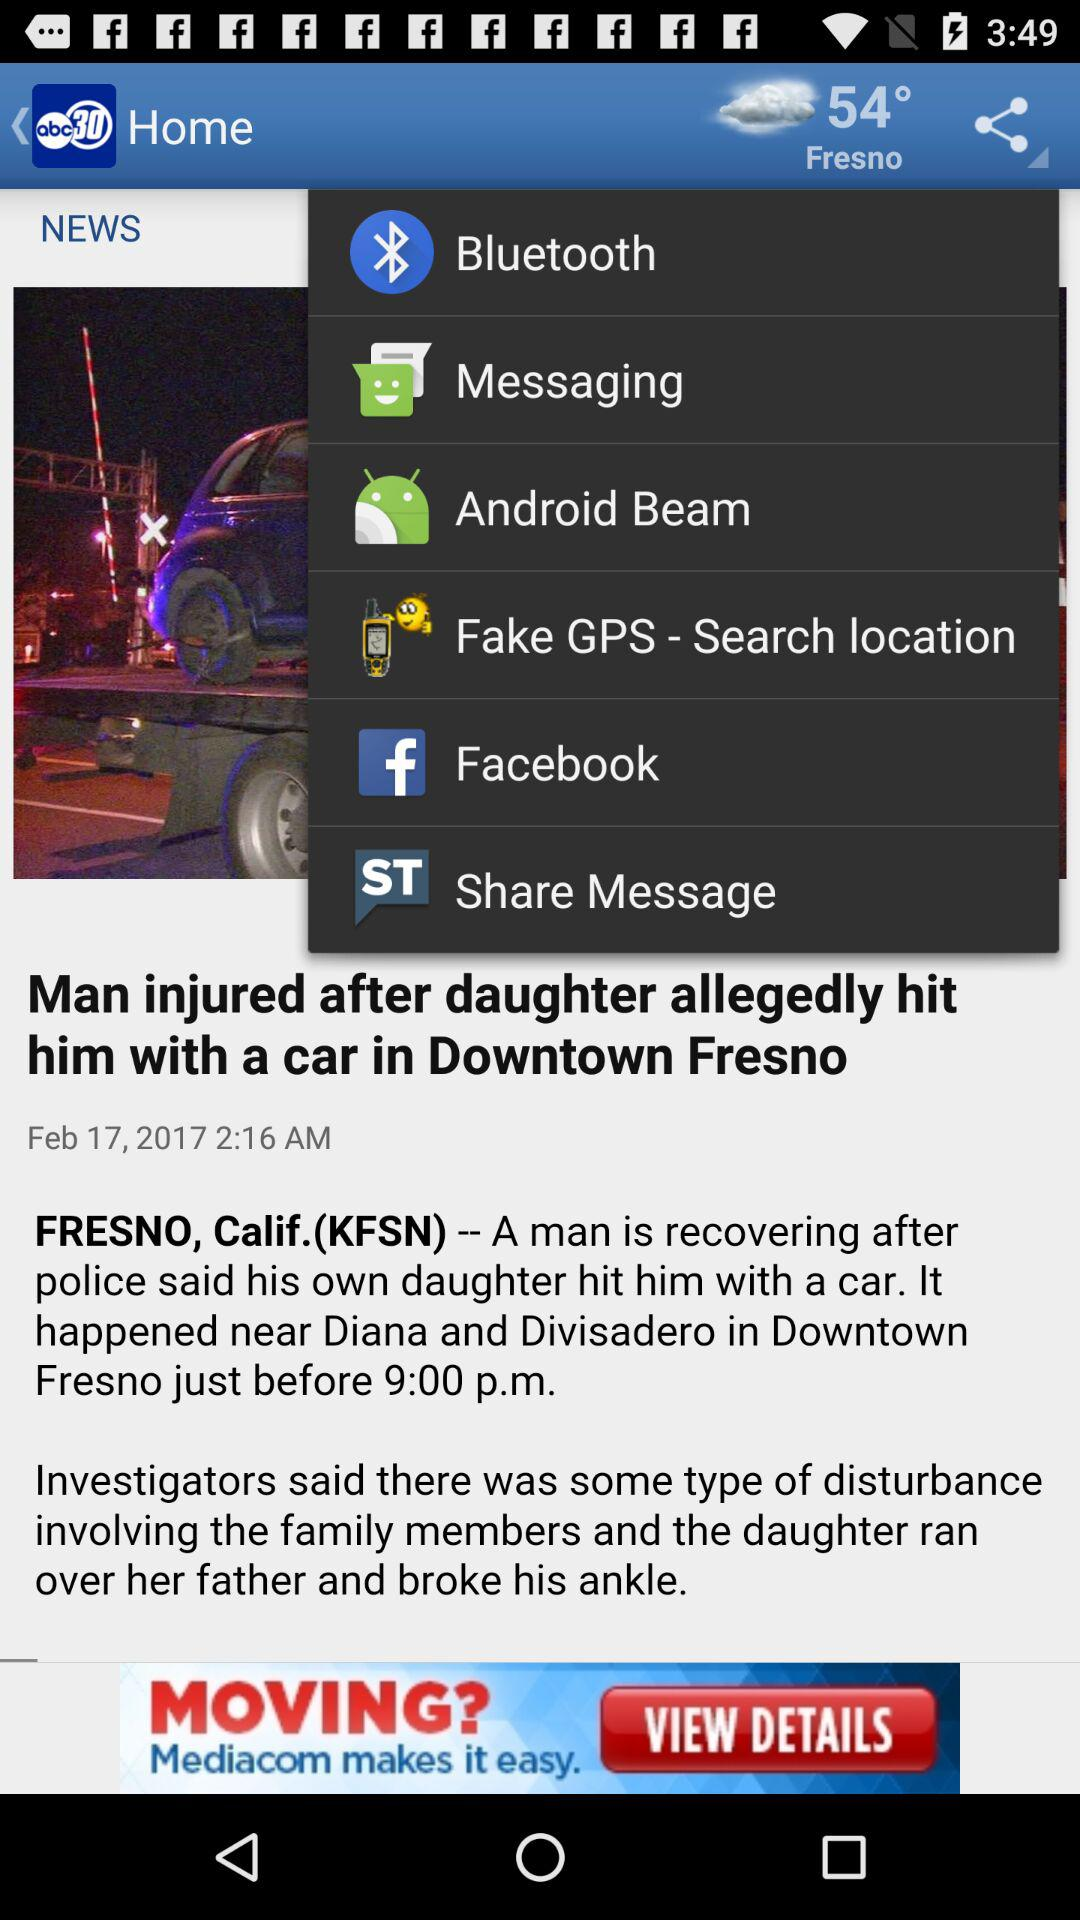What sharing options can I use to share the content? The sharing options that you can use to share the content are "Bluetooth", "Messaging", "Android Beam", "Fake GPS - Search location", "Facebook" and "Share Message". 